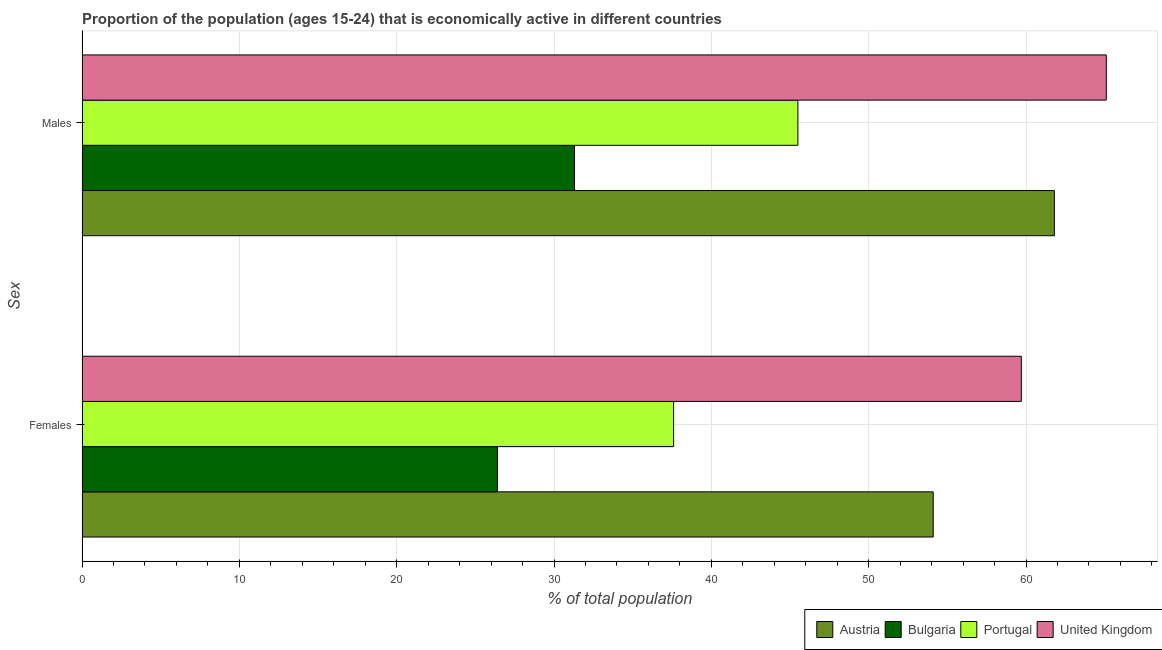How many groups of bars are there?
Offer a very short reply. 2. Are the number of bars per tick equal to the number of legend labels?
Provide a short and direct response. Yes. Are the number of bars on each tick of the Y-axis equal?
Offer a terse response. Yes. How many bars are there on the 1st tick from the bottom?
Give a very brief answer. 4. What is the label of the 2nd group of bars from the top?
Provide a succinct answer. Females. What is the percentage of economically active female population in United Kingdom?
Provide a succinct answer. 59.7. Across all countries, what is the maximum percentage of economically active male population?
Offer a terse response. 65.1. Across all countries, what is the minimum percentage of economically active male population?
Keep it short and to the point. 31.3. What is the total percentage of economically active female population in the graph?
Offer a very short reply. 177.8. What is the difference between the percentage of economically active male population in Portugal and that in Austria?
Offer a terse response. -16.3. What is the difference between the percentage of economically active male population in Bulgaria and the percentage of economically active female population in Austria?
Offer a terse response. -22.8. What is the average percentage of economically active female population per country?
Offer a very short reply. 44.45. What is the difference between the percentage of economically active male population and percentage of economically active female population in United Kingdom?
Provide a short and direct response. 5.4. What is the ratio of the percentage of economically active male population in United Kingdom to that in Portugal?
Provide a short and direct response. 1.43. In how many countries, is the percentage of economically active male population greater than the average percentage of economically active male population taken over all countries?
Your response must be concise. 2. What does the 2nd bar from the bottom in Males represents?
Keep it short and to the point. Bulgaria. Are all the bars in the graph horizontal?
Give a very brief answer. Yes. What is the difference between two consecutive major ticks on the X-axis?
Give a very brief answer. 10. Are the values on the major ticks of X-axis written in scientific E-notation?
Provide a short and direct response. No. Where does the legend appear in the graph?
Your response must be concise. Bottom right. How many legend labels are there?
Provide a short and direct response. 4. How are the legend labels stacked?
Provide a short and direct response. Horizontal. What is the title of the graph?
Provide a short and direct response. Proportion of the population (ages 15-24) that is economically active in different countries. What is the label or title of the X-axis?
Give a very brief answer. % of total population. What is the label or title of the Y-axis?
Your response must be concise. Sex. What is the % of total population in Austria in Females?
Offer a terse response. 54.1. What is the % of total population in Bulgaria in Females?
Give a very brief answer. 26.4. What is the % of total population in Portugal in Females?
Keep it short and to the point. 37.6. What is the % of total population in United Kingdom in Females?
Give a very brief answer. 59.7. What is the % of total population in Austria in Males?
Offer a very short reply. 61.8. What is the % of total population of Bulgaria in Males?
Your response must be concise. 31.3. What is the % of total population of Portugal in Males?
Offer a terse response. 45.5. What is the % of total population of United Kingdom in Males?
Your response must be concise. 65.1. Across all Sex, what is the maximum % of total population of Austria?
Make the answer very short. 61.8. Across all Sex, what is the maximum % of total population of Bulgaria?
Your response must be concise. 31.3. Across all Sex, what is the maximum % of total population in Portugal?
Offer a very short reply. 45.5. Across all Sex, what is the maximum % of total population of United Kingdom?
Offer a terse response. 65.1. Across all Sex, what is the minimum % of total population of Austria?
Provide a succinct answer. 54.1. Across all Sex, what is the minimum % of total population in Bulgaria?
Provide a short and direct response. 26.4. Across all Sex, what is the minimum % of total population of Portugal?
Your response must be concise. 37.6. Across all Sex, what is the minimum % of total population in United Kingdom?
Offer a very short reply. 59.7. What is the total % of total population of Austria in the graph?
Ensure brevity in your answer.  115.9. What is the total % of total population of Bulgaria in the graph?
Your response must be concise. 57.7. What is the total % of total population of Portugal in the graph?
Keep it short and to the point. 83.1. What is the total % of total population in United Kingdom in the graph?
Your response must be concise. 124.8. What is the difference between the % of total population of Bulgaria in Females and that in Males?
Your answer should be compact. -4.9. What is the difference between the % of total population in Portugal in Females and that in Males?
Your answer should be compact. -7.9. What is the difference between the % of total population in Austria in Females and the % of total population in Bulgaria in Males?
Provide a succinct answer. 22.8. What is the difference between the % of total population of Austria in Females and the % of total population of Portugal in Males?
Your answer should be compact. 8.6. What is the difference between the % of total population in Bulgaria in Females and the % of total population in Portugal in Males?
Make the answer very short. -19.1. What is the difference between the % of total population in Bulgaria in Females and the % of total population in United Kingdom in Males?
Provide a succinct answer. -38.7. What is the difference between the % of total population of Portugal in Females and the % of total population of United Kingdom in Males?
Your response must be concise. -27.5. What is the average % of total population of Austria per Sex?
Your answer should be compact. 57.95. What is the average % of total population in Bulgaria per Sex?
Your response must be concise. 28.85. What is the average % of total population in Portugal per Sex?
Your answer should be very brief. 41.55. What is the average % of total population in United Kingdom per Sex?
Provide a succinct answer. 62.4. What is the difference between the % of total population of Austria and % of total population of Bulgaria in Females?
Your answer should be very brief. 27.7. What is the difference between the % of total population in Austria and % of total population in Portugal in Females?
Provide a short and direct response. 16.5. What is the difference between the % of total population in Bulgaria and % of total population in United Kingdom in Females?
Your answer should be very brief. -33.3. What is the difference between the % of total population of Portugal and % of total population of United Kingdom in Females?
Provide a succinct answer. -22.1. What is the difference between the % of total population of Austria and % of total population of Bulgaria in Males?
Your answer should be very brief. 30.5. What is the difference between the % of total population in Austria and % of total population in United Kingdom in Males?
Offer a terse response. -3.3. What is the difference between the % of total population of Bulgaria and % of total population of Portugal in Males?
Ensure brevity in your answer.  -14.2. What is the difference between the % of total population in Bulgaria and % of total population in United Kingdom in Males?
Provide a short and direct response. -33.8. What is the difference between the % of total population in Portugal and % of total population in United Kingdom in Males?
Offer a very short reply. -19.6. What is the ratio of the % of total population of Austria in Females to that in Males?
Your answer should be compact. 0.88. What is the ratio of the % of total population in Bulgaria in Females to that in Males?
Your answer should be very brief. 0.84. What is the ratio of the % of total population of Portugal in Females to that in Males?
Ensure brevity in your answer.  0.83. What is the ratio of the % of total population in United Kingdom in Females to that in Males?
Ensure brevity in your answer.  0.92. What is the difference between the highest and the second highest % of total population of Austria?
Give a very brief answer. 7.7. What is the difference between the highest and the second highest % of total population of Bulgaria?
Your answer should be compact. 4.9. What is the difference between the highest and the second highest % of total population in United Kingdom?
Your answer should be compact. 5.4. What is the difference between the highest and the lowest % of total population in Portugal?
Offer a very short reply. 7.9. 